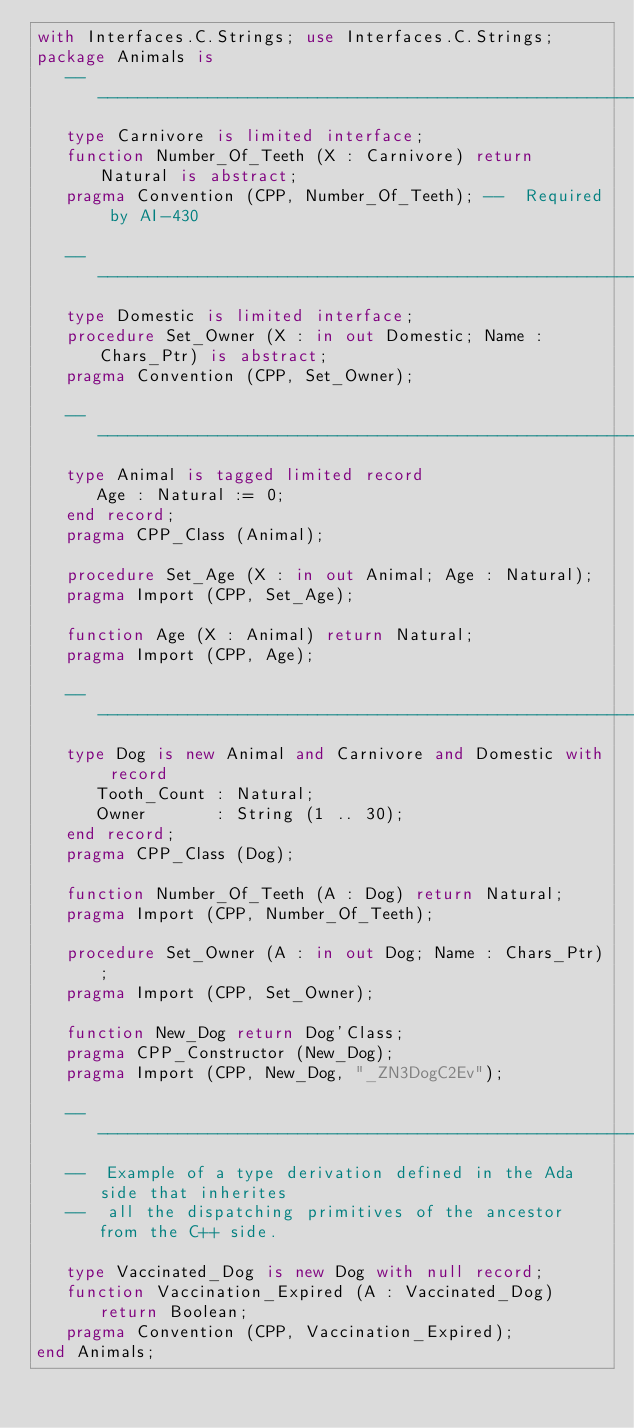<code> <loc_0><loc_0><loc_500><loc_500><_Ada_>with Interfaces.C.Strings; use Interfaces.C.Strings;
package Animals is
   --  -----------------------------------------------------------------------
   type Carnivore is limited interface;
   function Number_Of_Teeth (X : Carnivore) return Natural is abstract;
   pragma Convention (CPP, Number_Of_Teeth); --  Required by AI-430

   --  -----------------------------------------------------------------------
   type Domestic is limited interface;
   procedure Set_Owner (X : in out Domestic; Name : Chars_Ptr) is abstract;
   pragma Convention (CPP, Set_Owner);

   --  -----------------------------------------------------------------------
   type Animal is tagged limited record
      Age : Natural := 0;
   end record;
   pragma CPP_Class (Animal);

   procedure Set_Age (X : in out Animal; Age : Natural);
   pragma Import (CPP, Set_Age);

   function Age (X : Animal) return Natural;
   pragma Import (CPP, Age);

   --  -----------------------------------------------------------------------
   type Dog is new Animal and Carnivore and Domestic with record
      Tooth_Count : Natural;
      Owner       : String (1 .. 30);
   end record;
   pragma CPP_Class (Dog);

   function Number_Of_Teeth (A : Dog) return Natural;
   pragma Import (CPP, Number_Of_Teeth);

   procedure Set_Owner (A : in out Dog; Name : Chars_Ptr);
   pragma Import (CPP, Set_Owner);

   function New_Dog return Dog'Class;
   pragma CPP_Constructor (New_Dog);
   pragma Import (CPP, New_Dog, "_ZN3DogC2Ev");

   --  -----------------------------------------------------------------------
   --  Example of a type derivation defined in the Ada side that inherites
   --  all the dispatching primitives of the ancestor from the C++ side.

   type Vaccinated_Dog is new Dog with null record;
   function Vaccination_Expired (A : Vaccinated_Dog) return Boolean;
   pragma Convention (CPP, Vaccination_Expired); 
end Animals;
</code> 